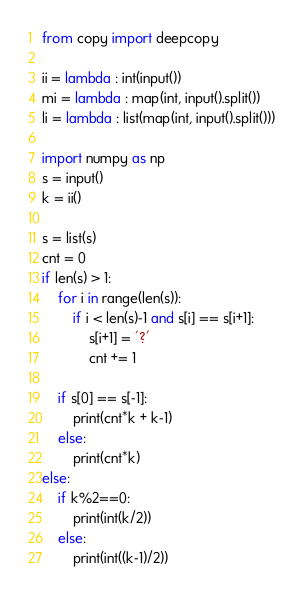Convert code to text. <code><loc_0><loc_0><loc_500><loc_500><_Python_>from copy import deepcopy

ii = lambda : int(input())
mi = lambda : map(int, input().split())
li = lambda : list(map(int, input().split()))

import numpy as np
s = input()
k = ii()

s = list(s)
cnt = 0
if len(s) > 1:
    for i in range(len(s)):
        if i < len(s)-1 and s[i] == s[i+1]:
            s[i+1] = '?'
            cnt += 1

    if s[0] == s[-1]:
        print(cnt*k + k-1)
    else:
        print(cnt*k)
else:
    if k%2==0:
        print(int(k/2))
    else:
        print(int((k-1)/2))
</code> 